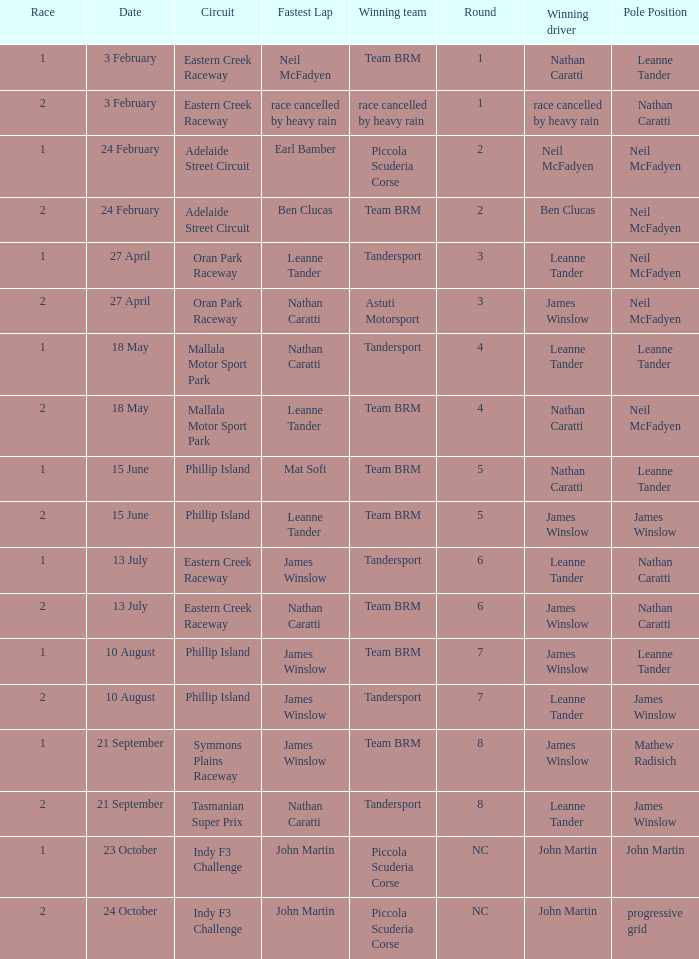Which race number in the Indy F3 Challenge circuit had John Martin in pole position? 1.0. 